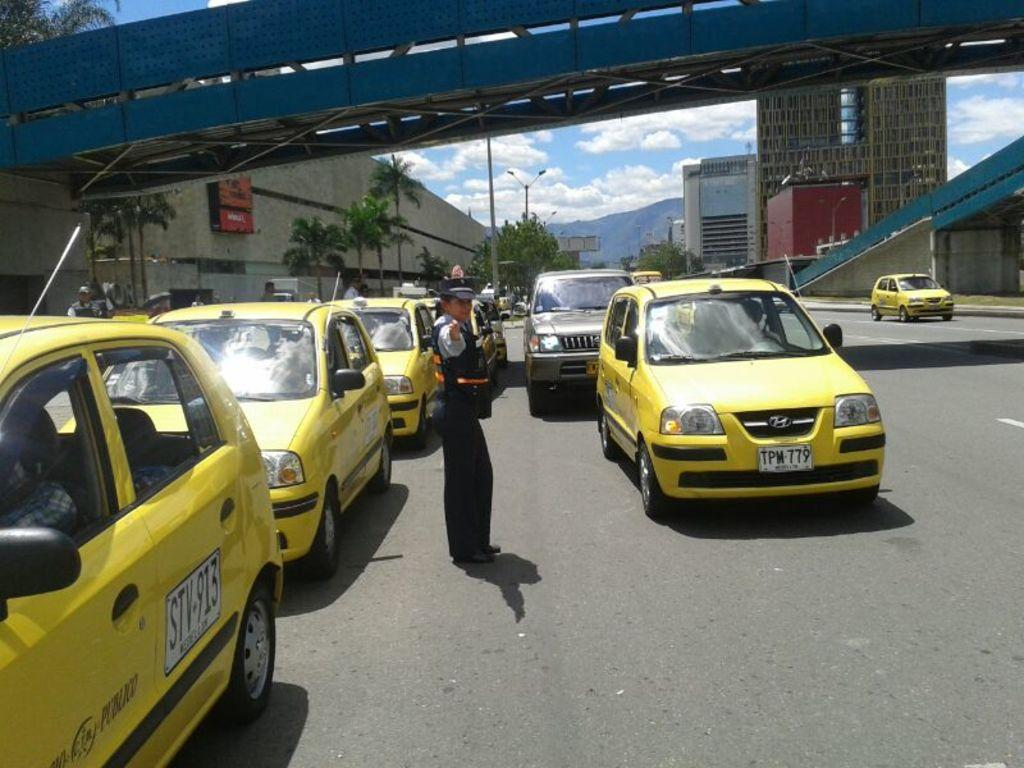<image>
Summarize the visual content of the image. A female police officer stands in the middle of the street as a yellow cab with the plate TPM 779 drives by. 